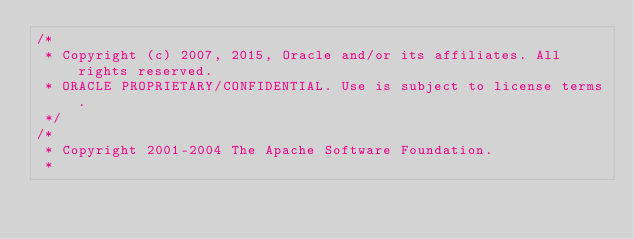Convert code to text. <code><loc_0><loc_0><loc_500><loc_500><_Java_>/*
 * Copyright (c) 2007, 2015, Oracle and/or its affiliates. All rights reserved.
 * ORACLE PROPRIETARY/CONFIDENTIAL. Use is subject to license terms.
 */
/*
 * Copyright 2001-2004 The Apache Software Foundation.
 *</code> 